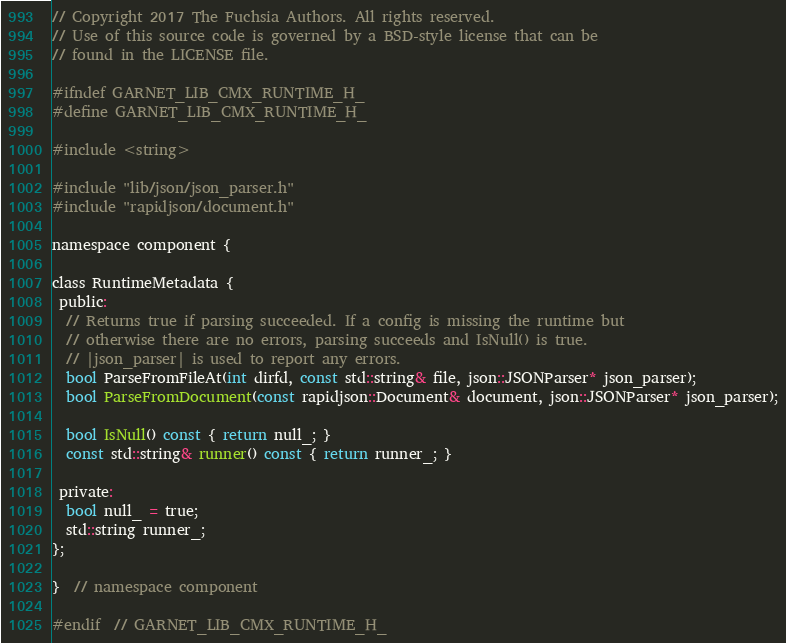Convert code to text. <code><loc_0><loc_0><loc_500><loc_500><_C_>// Copyright 2017 The Fuchsia Authors. All rights reserved.
// Use of this source code is governed by a BSD-style license that can be
// found in the LICENSE file.

#ifndef GARNET_LIB_CMX_RUNTIME_H_
#define GARNET_LIB_CMX_RUNTIME_H_

#include <string>

#include "lib/json/json_parser.h"
#include "rapidjson/document.h"

namespace component {

class RuntimeMetadata {
 public:
  // Returns true if parsing succeeded. If a config is missing the runtime but
  // otherwise there are no errors, parsing succeeds and IsNull() is true.
  // |json_parser| is used to report any errors.
  bool ParseFromFileAt(int dirfd, const std::string& file, json::JSONParser* json_parser);
  bool ParseFromDocument(const rapidjson::Document& document, json::JSONParser* json_parser);

  bool IsNull() const { return null_; }
  const std::string& runner() const { return runner_; }

 private:
  bool null_ = true;
  std::string runner_;
};

}  // namespace component

#endif  // GARNET_LIB_CMX_RUNTIME_H_
</code> 